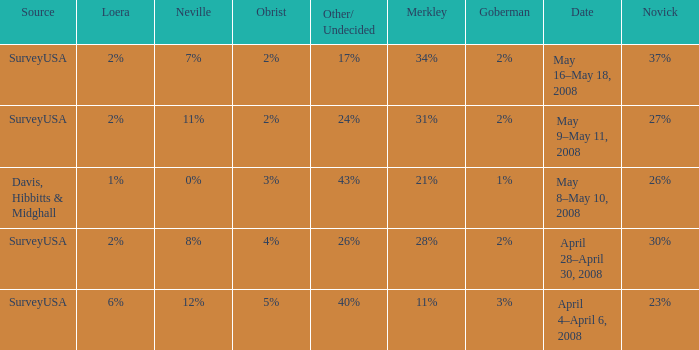Which Date has a Novick of 26%? May 8–May 10, 2008. 